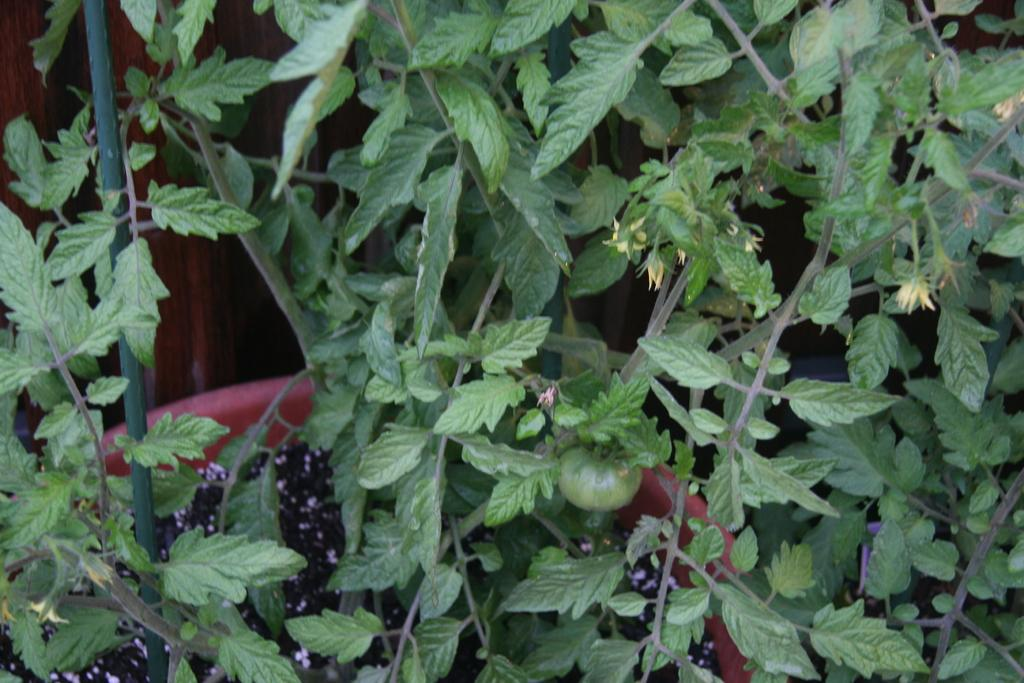What type of plant material can be seen in the image? There are leaves, flowers, and fruits in the image. What is the container for the plants in the image? There is a pot in the image. How many frogs are sitting on the lip of the pot in the image? There are no frogs present in the image. What type of alarm is going off in the image? There is no alarm present in the image. 